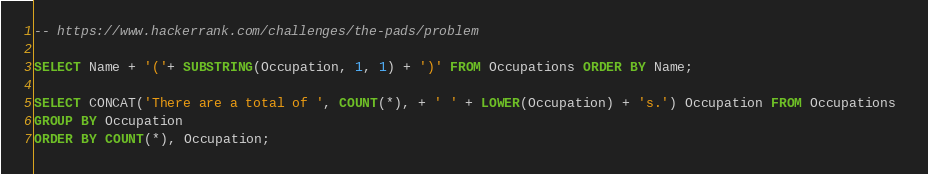<code> <loc_0><loc_0><loc_500><loc_500><_SQL_>-- https://www.hackerrank.com/challenges/the-pads/problem

SELECT Name + '('+ SUBSTRING(Occupation, 1, 1) + ')' FROM Occupations ORDER BY Name;

SELECT CONCAT('There are a total of ', COUNT(*), + ' ' + LOWER(Occupation) + 's.') Occupation FROM Occupations 
GROUP BY Occupation
ORDER BY COUNT(*), Occupation;</code> 